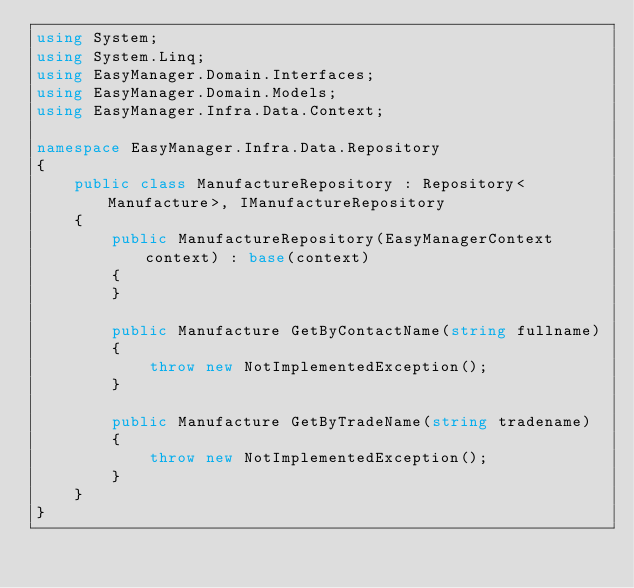Convert code to text. <code><loc_0><loc_0><loc_500><loc_500><_C#_>using System;
using System.Linq;
using EasyManager.Domain.Interfaces;
using EasyManager.Domain.Models;
using EasyManager.Infra.Data.Context;

namespace EasyManager.Infra.Data.Repository
{
    public class ManufactureRepository : Repository<Manufacture>, IManufactureRepository
    {
        public ManufactureRepository(EasyManagerContext context) : base(context)
        {
        }

        public Manufacture GetByContactName(string fullname)
        {
            throw new NotImplementedException();
        }

        public Manufacture GetByTradeName(string tradename)
        {
            throw new NotImplementedException();
        }
    }
}</code> 